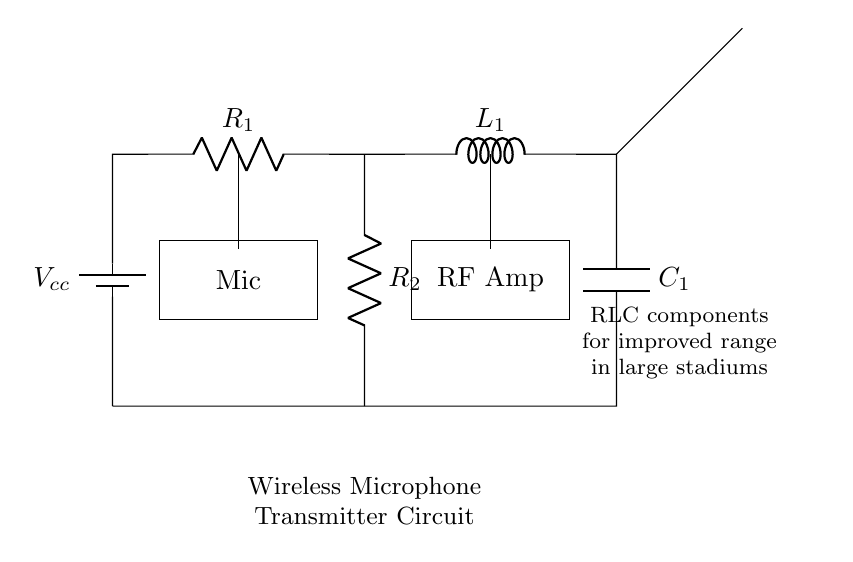What is the voltage supply in the circuit? The circuit shows a battery labeled Vcc, indicating it serves as a voltage supply. Thus, the voltage is represented by the label under the battery.
Answer: Vcc How many resistors are present in the diagram? By examining the diagram, there are two components labeled R1 and R2, both of which are resistors. Therefore, the total count of resistors is two.
Answer: 2 What is the role of the antenna in this circuit? The antenna in the diagram is used for transmitting radio frequency signals, indicating it is integral in the wireless transmission process of the microphone.
Answer: Transmission Which components are connected in series in the circuit? The components connected in series are Vcc, R1, L1, and C1, as they are sequentially connected from the battery to the ground without any branches in between.
Answer: Vcc, R1, L1, C1 What is the function of the inductor in the circuit? The inductor in this circuit is primarily used for energy storage and filtering, which contributes to the overall frequency response and range improvements for wireless transmission.
Answer: Energy storage What is the relationship between resistance and frequency in this RLC circuit? In an RLC circuit, resistance affects the damping of oscillations, which in turn impacts the bandwidth and quality of the frequency response, thereby influencing signal clarity and range.
Answer: Damping effect How do you expect the capacitor to behave in this circuit? The capacitor will charge and discharge based on the alternating current, affecting the overall reactance and enabling the tuning of the circuit to desired frequencies for better transmission.
Answer: Charge and discharge 